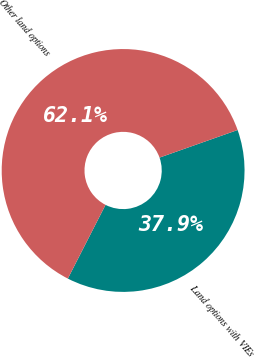<chart> <loc_0><loc_0><loc_500><loc_500><pie_chart><fcel>Land options with VIEs<fcel>Other land options<nl><fcel>37.93%<fcel>62.07%<nl></chart> 